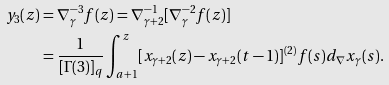Convert formula to latex. <formula><loc_0><loc_0><loc_500><loc_500>y _ { 3 } ( z ) & = \nabla _ { \gamma } ^ { - 3 } f ( z ) = \nabla _ { \gamma + 2 } ^ { - 1 } [ \nabla _ { \gamma } ^ { - 2 } f ( z ) ] \\ & = \frac { 1 } { [ \Gamma ( 3 ) ] _ { q } } \int _ { a + 1 } ^ { z } [ x _ { \gamma + 2 } ( z ) - x _ { \gamma + 2 } ( t - 1 ) ] ^ { ( 2 ) } f ( s ) d _ { \nabla } x _ { \gamma } ( s ) .</formula> 